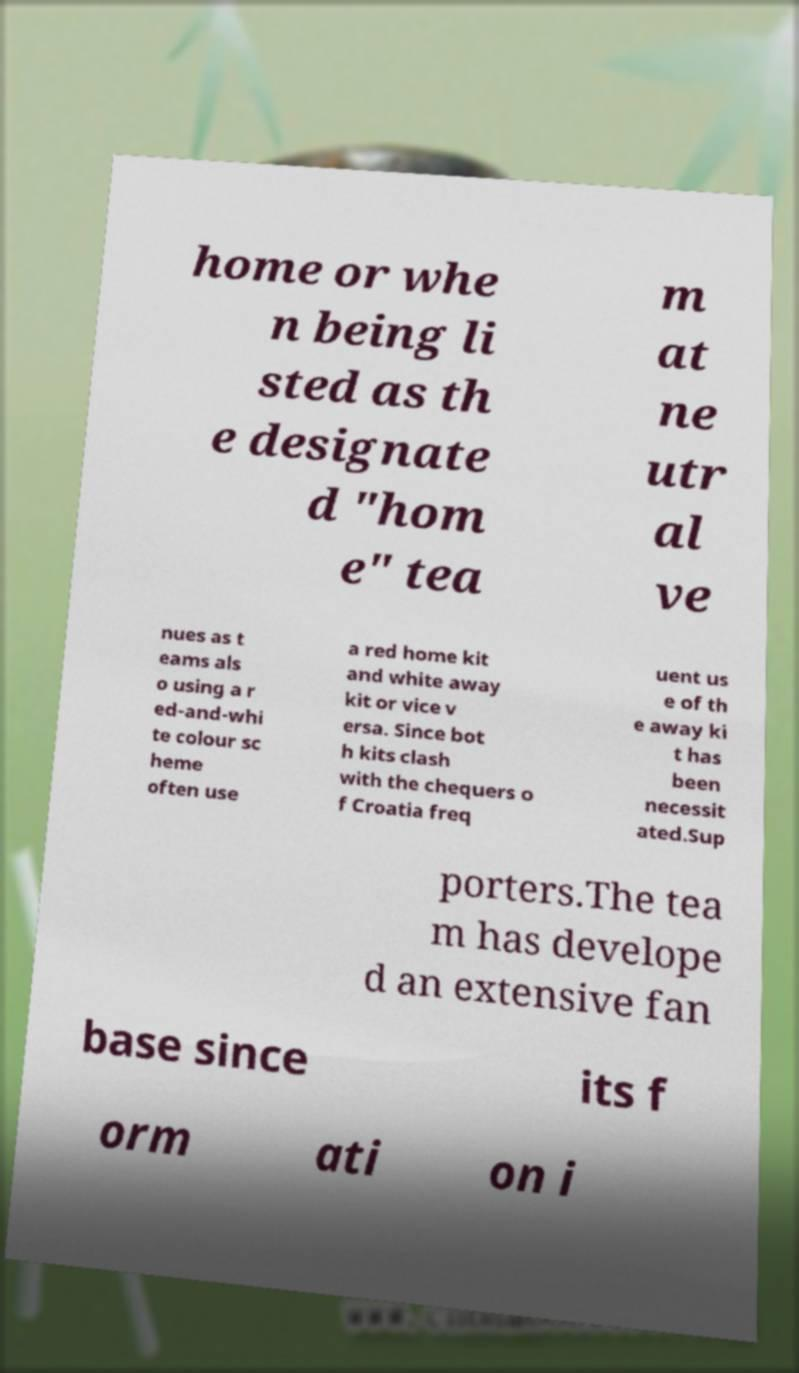Could you extract and type out the text from this image? home or whe n being li sted as th e designate d "hom e" tea m at ne utr al ve nues as t eams als o using a r ed-and-whi te colour sc heme often use a red home kit and white away kit or vice v ersa. Since bot h kits clash with the chequers o f Croatia freq uent us e of th e away ki t has been necessit ated.Sup porters.The tea m has develope d an extensive fan base since its f orm ati on i 